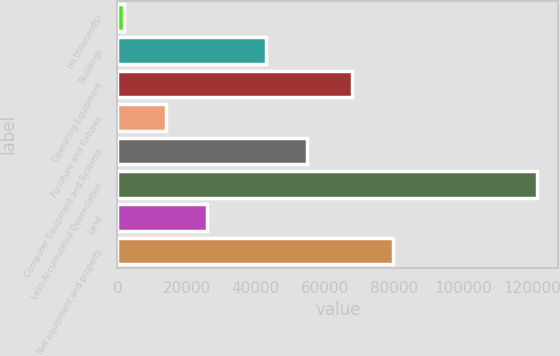Convert chart. <chart><loc_0><loc_0><loc_500><loc_500><bar_chart><fcel>(in thousands)<fcel>Buildings<fcel>Operating Equipment<fcel>Furniture and Fixtures<fcel>Computer Equipment and Systems<fcel>Less-Accumulated Depreciation<fcel>Land<fcel>Net equipment and property<nl><fcel>2010<fcel>42995<fcel>67739<fcel>13963<fcel>54948<fcel>121540<fcel>25916<fcel>79692<nl></chart> 